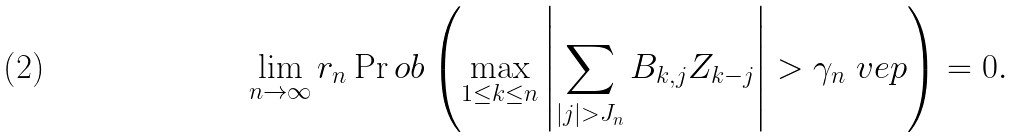<formula> <loc_0><loc_0><loc_500><loc_500>\lim _ { n \to \infty } r _ { n } \Pr o b \left ( \max _ { 1 \leq k \leq n } \left | \sum _ { | j | > J _ { n } } B _ { k , j } Z _ { k - j } \right | > \gamma _ { n } \ v e p \right ) = 0 .</formula> 